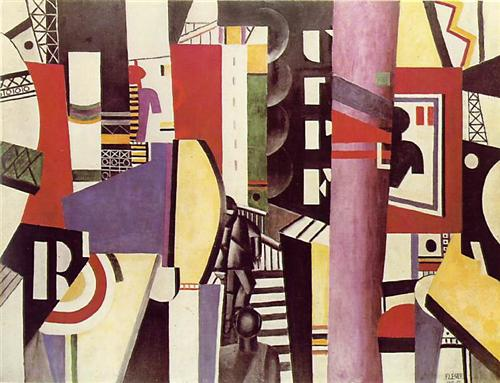Identify the elements that you think make this piece a work of Cubism. Several elements in this piece exemplify Cubism: the fragmented geometric shapes, overlapping planes, and multiple perspectives all work together to deconstruct the conventional representation of objects. By breaking down and reassembling forms, the artist defies traditional notions of perception and perspective. The varied use of color adds another layer of complexity, emphasizing the structural and dynamic qualities of the composition. The de-emphasis on realistic depiction, favoring instead abstract forms, and the interplay between light and shadow, all highlight its Cubist characteristics. 